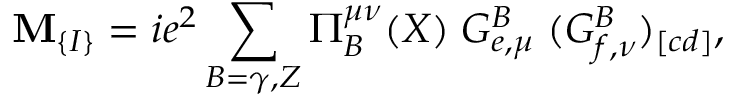<formula> <loc_0><loc_0><loc_500><loc_500>M _ { \{ I \} } = i e ^ { 2 } \sum _ { B = \gamma , Z } \Pi _ { B } ^ { \mu \nu } ( X ) \, G _ { e , \mu } ^ { B } \, ( G _ { f , \nu } ^ { B } ) _ { [ c d ] } ,</formula> 